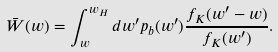Convert formula to latex. <formula><loc_0><loc_0><loc_500><loc_500>\bar { W } ( w ) = \int _ { w } ^ { w _ { H } } d w ^ { \prime } p _ { b } ( w ^ { \prime } ) \frac { f _ { K } ( w ^ { \prime } - w ) } { f _ { K } ( w ^ { \prime } ) } .</formula> 